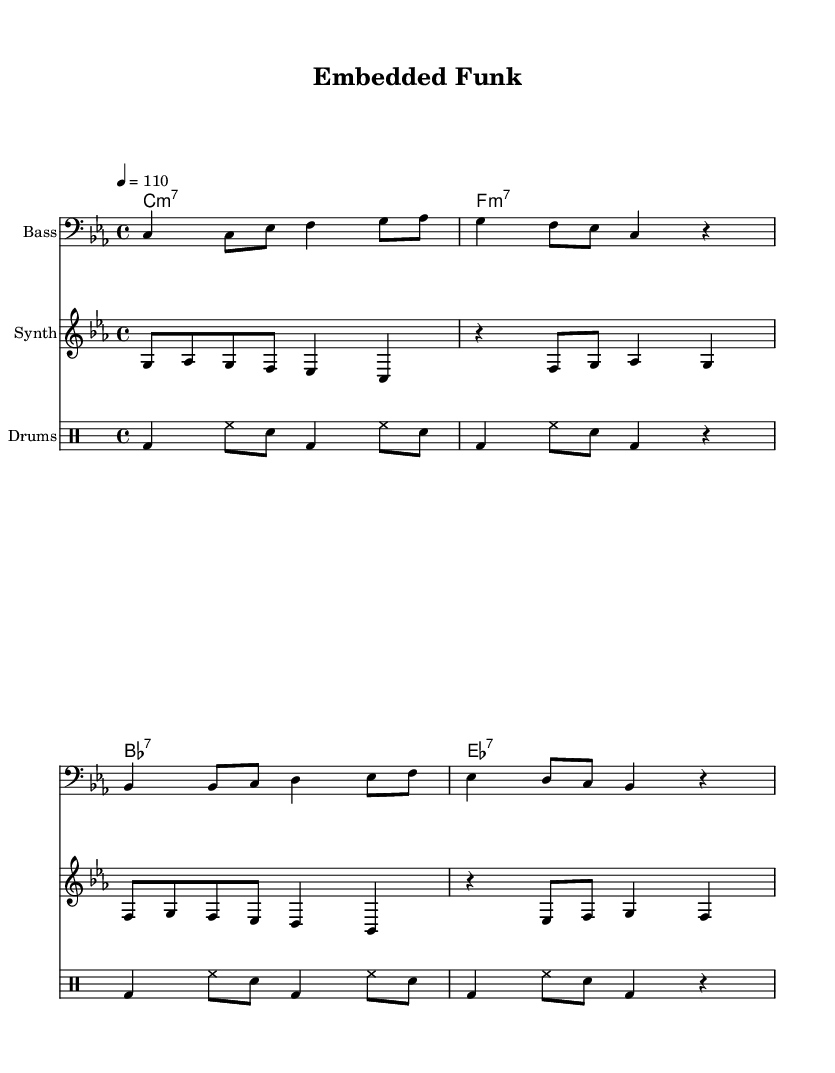what is the key signature of this music? The key signature indicates that this piece is in C minor, which has three flats: B flat, E flat, and A flat. This can be determined from the 'key c \minor' declaration in the global section.
Answer: C minor what is the time signature of this music? The time signature is found in the global section where it is stated as '4/4', meaning each measure contains four beats. This is denoted directly after the key signature declaration.
Answer: 4/4 what is the tempo marking of this music? The tempo marking is indicated in the global section as '4 = 110', which means there are 110 beats per minute. This shows how fast the music should be played.
Answer: 110 how many measures are there in the bass line? By counting the number of distinct musical phrases separated by bar lines in the bassLine variable, we see that there are four measures present.
Answer: 4 what is the instrument for the first staff in the score? The first staff in the score is labeled with 'Bass', which specifies that it is intended for the bass instrument. This is indicated by the 'instrumentName' parameter in the staff settings.
Answer: Bass which chord follows the C minor 7 chord in this piece? The chord progression indicates that after C minor 7, the next chord is F minor 7. This is determined by looking at the chordNames variable where C1:m7 is followed by F1:m7.
Answer: F minor 7 what kind of rhythmic pattern is used in the drum part? The drum part consists of a repetitive pattern that features bass drum (bd), hi-hat (hh), and snare drum (sn) in a steady 4/4 rhythm. Each measure has a consistent pattern that repeats every two measures.
Answer: Bass and snare pattern 